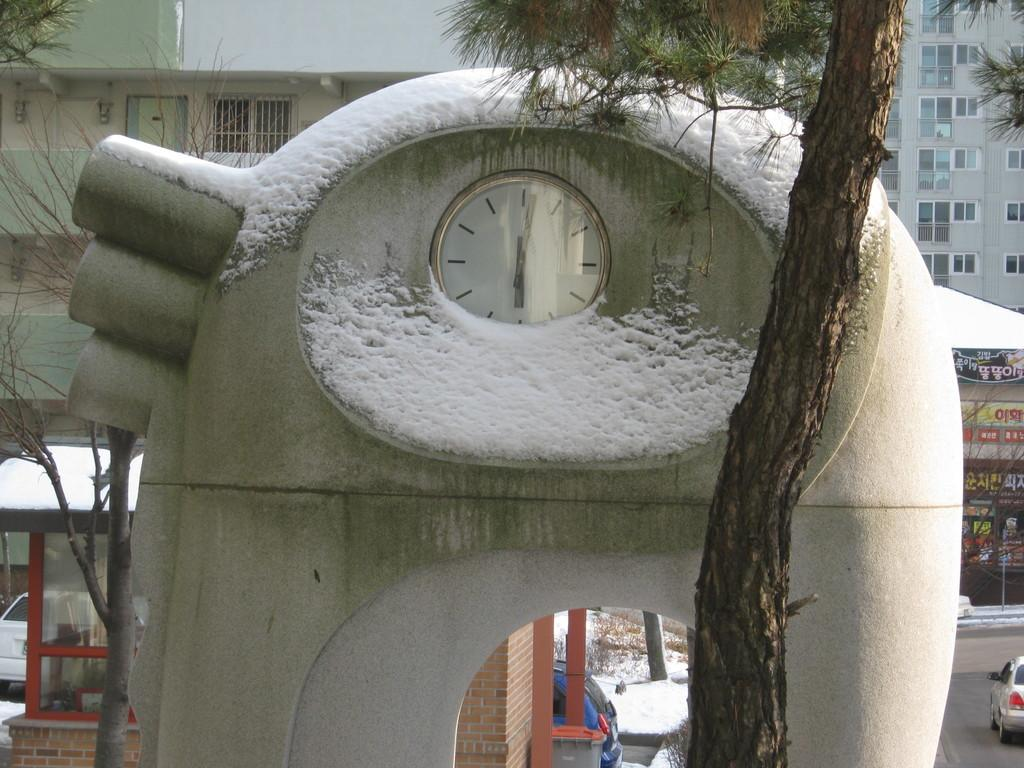What type of natural elements can be seen in the image? There are trees in the image. What structure with a timekeeping device is present in the image? There is an arch with a clock in the image. How is the clock affected by the weather in the image? The clock is covered with snow in the image. What type of man-made structures can be seen in the background of the image? There are buildings in the background of the image. What type of transportation is visible in the background of the image? There are vehicles in the background of the image. What type of waste disposal container is present in the background of the image? There is a dustbin in the background of the image. What is the title of the book that is being read by the person in the image? There is no person or book present in the image. What type of weather condition is affecting visibility in the image? The image does not depict any fog or reduced visibility due to weather conditions. 